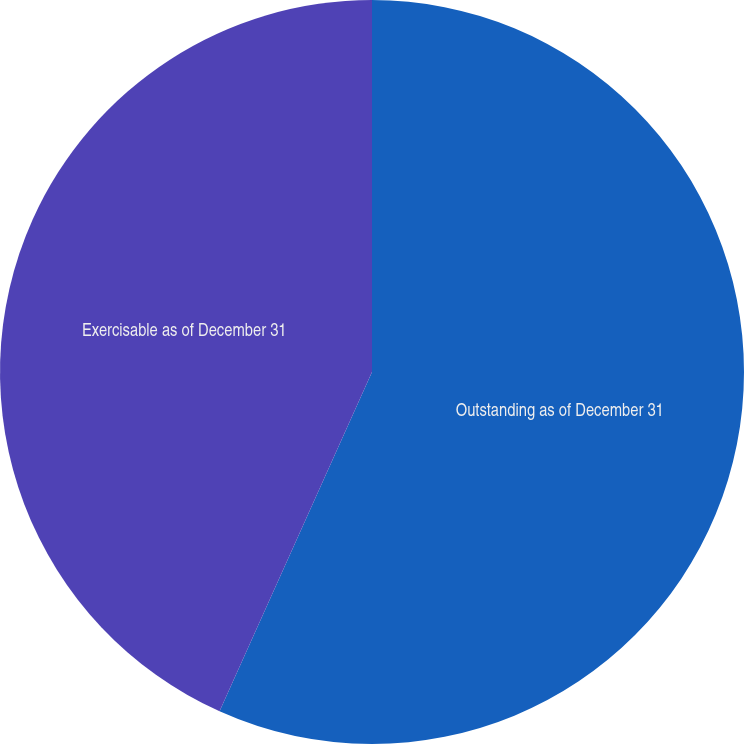<chart> <loc_0><loc_0><loc_500><loc_500><pie_chart><fcel>Outstanding as of December 31<fcel>Exercisable as of December 31<nl><fcel>56.72%<fcel>43.28%<nl></chart> 